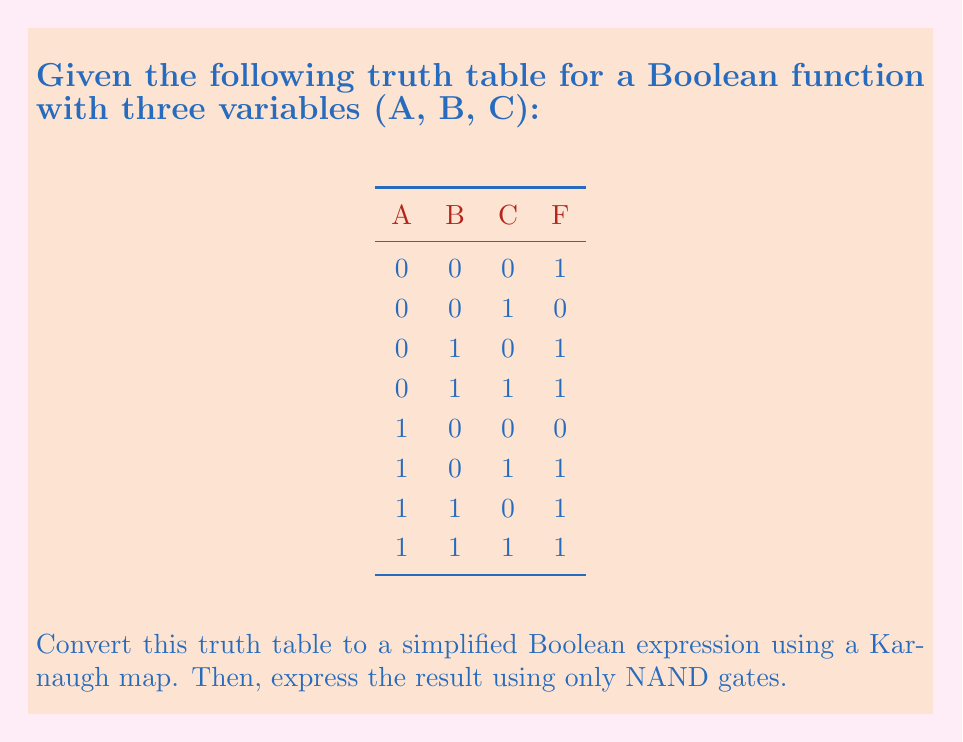Show me your answer to this math problem. Step 1: Create a Karnaugh map from the truth table.

[asy]
unitsize(1cm);
draw((0,0)--(4,0)--(4,2)--(0,2)--cycle);
draw((1,0)--(1,2));
draw((2,0)--(2,2));
draw((3,0)--(3,2));
draw((0,1)--(4,1));
label("00", (0.5,2.5));
label("01", (1.5,2.5));
label("11", (2.5,2.5));
label("10", (3.5,2.5));
label("0", (-0.5,1.5));
label("1", (-0.5,0.5));
label("1", (0.5,1.5));
label("0", (1.5,1.5));
label("1", (2.5,1.5));
label("0", (3.5,1.5));
label("0", (0.5,0.5));
label("1", (1.5,0.5));
label("1", (2.5,0.5));
label("1", (3.5,0.5));
label("AB", (-0.5,2.5));
label("C", (-1,1));
[/asy]

Step 2: Identify the largest groups of 1s in the Karnaugh map.
We can see two groups:
1. A group of four 1s in the bottom row (C = 1)
2. A group of two 1s in the left column (A = 0, B = 0)

Step 3: Write the Boolean expression based on these groups.
$F = C + \overline{A}\overline{B}$

Step 4: To express this using only NAND gates, we can use the following identities:
1. $\overline{X} = X \text{ NAND } X$
2. $X + Y = \overline{\overline{X} \cdot \overline{Y}} = (\overline{X} \text{ NAND } \overline{Y})$

First, let's create $\overline{A}$ and $\overline{B}$:
$\overline{A} = A \text{ NAND } A$
$\overline{B} = B \text{ NAND } B$

Then, we can create $\overline{A}\overline{B}$:
$\overline{A}\overline{B} = (A \text{ NAND } A) \text{ NAND } (B \text{ NAND } B)$

Finally, we combine this with C using the second identity:
$F = C + \overline{A}\overline{B} = (C \text{ NAND } C) \text{ NAND } ((A \text{ NAND } A) \text{ NAND } (B \text{ NAND } B))$
Answer: $F = (C \text{ NAND } C) \text{ NAND } ((A \text{ NAND } A) \text{ NAND } (B \text{ NAND } B))$ 